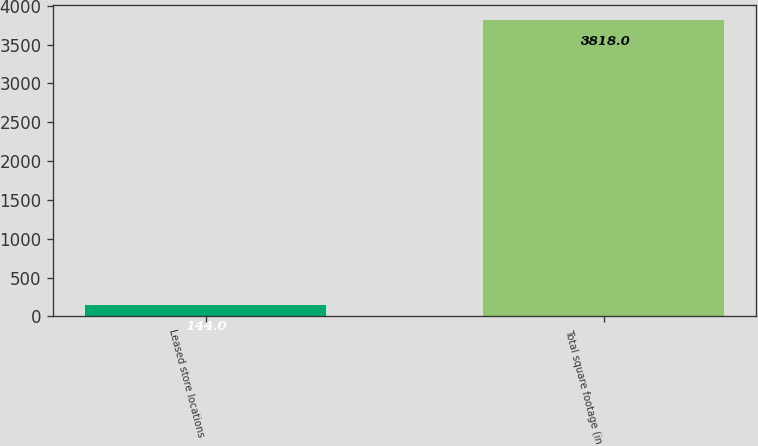Convert chart to OTSL. <chart><loc_0><loc_0><loc_500><loc_500><bar_chart><fcel>Leased store locations<fcel>Total square footage (in<nl><fcel>144<fcel>3818<nl></chart> 